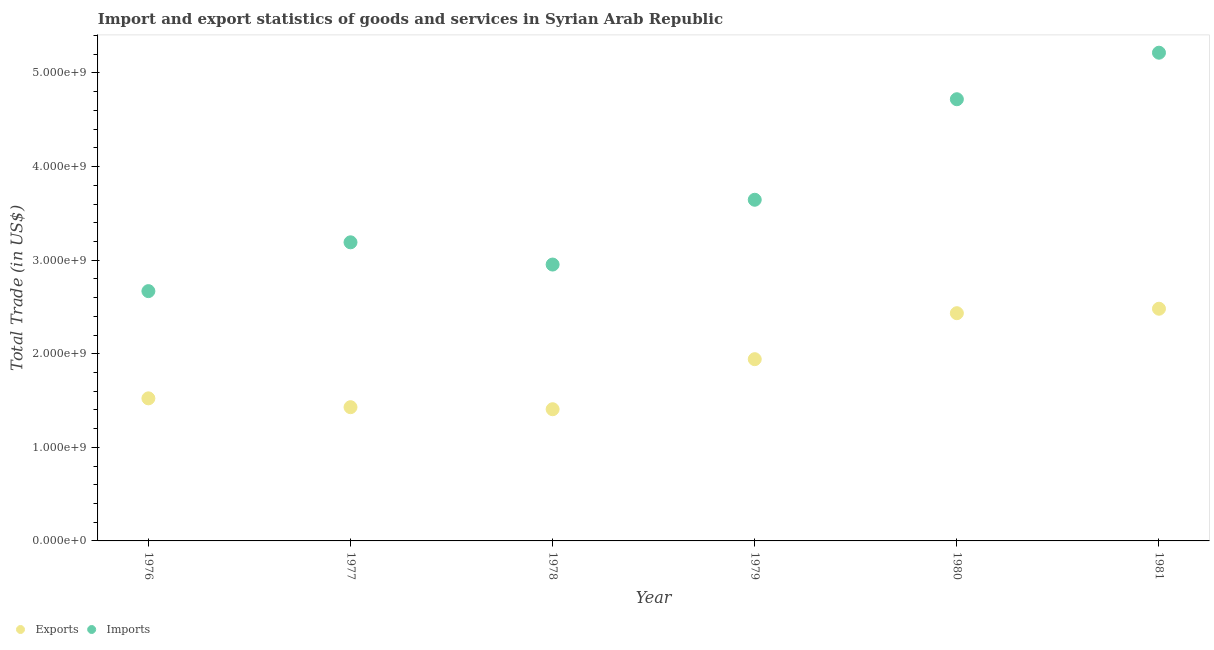What is the imports of goods and services in 1976?
Your response must be concise. 2.67e+09. Across all years, what is the maximum export of goods and services?
Your response must be concise. 2.48e+09. Across all years, what is the minimum export of goods and services?
Make the answer very short. 1.41e+09. In which year was the export of goods and services maximum?
Keep it short and to the point. 1981. In which year was the imports of goods and services minimum?
Give a very brief answer. 1976. What is the total imports of goods and services in the graph?
Your answer should be very brief. 2.24e+1. What is the difference between the imports of goods and services in 1979 and that in 1981?
Provide a succinct answer. -1.57e+09. What is the difference between the export of goods and services in 1979 and the imports of goods and services in 1977?
Provide a succinct answer. -1.25e+09. What is the average imports of goods and services per year?
Make the answer very short. 3.73e+09. In the year 1979, what is the difference between the export of goods and services and imports of goods and services?
Your response must be concise. -1.70e+09. In how many years, is the imports of goods and services greater than 1400000000 US$?
Your response must be concise. 6. What is the ratio of the export of goods and services in 1976 to that in 1980?
Offer a terse response. 0.63. Is the imports of goods and services in 1976 less than that in 1977?
Your answer should be compact. Yes. What is the difference between the highest and the second highest export of goods and services?
Provide a succinct answer. 4.78e+07. What is the difference between the highest and the lowest imports of goods and services?
Ensure brevity in your answer.  2.55e+09. Does the imports of goods and services monotonically increase over the years?
Ensure brevity in your answer.  No. Is the imports of goods and services strictly greater than the export of goods and services over the years?
Provide a short and direct response. Yes. How many dotlines are there?
Your answer should be compact. 2. How many years are there in the graph?
Provide a succinct answer. 6. What is the difference between two consecutive major ticks on the Y-axis?
Provide a short and direct response. 1.00e+09. What is the title of the graph?
Your answer should be compact. Import and export statistics of goods and services in Syrian Arab Republic. Does "Register a property" appear as one of the legend labels in the graph?
Ensure brevity in your answer.  No. What is the label or title of the X-axis?
Provide a succinct answer. Year. What is the label or title of the Y-axis?
Ensure brevity in your answer.  Total Trade (in US$). What is the Total Trade (in US$) in Exports in 1976?
Your response must be concise. 1.52e+09. What is the Total Trade (in US$) in Imports in 1976?
Your answer should be very brief. 2.67e+09. What is the Total Trade (in US$) in Exports in 1977?
Keep it short and to the point. 1.43e+09. What is the Total Trade (in US$) in Imports in 1977?
Provide a short and direct response. 3.19e+09. What is the Total Trade (in US$) in Exports in 1978?
Your response must be concise. 1.41e+09. What is the Total Trade (in US$) of Imports in 1978?
Make the answer very short. 2.95e+09. What is the Total Trade (in US$) in Exports in 1979?
Offer a terse response. 1.94e+09. What is the Total Trade (in US$) of Imports in 1979?
Your answer should be very brief. 3.65e+09. What is the Total Trade (in US$) in Exports in 1980?
Keep it short and to the point. 2.43e+09. What is the Total Trade (in US$) of Imports in 1980?
Give a very brief answer. 4.72e+09. What is the Total Trade (in US$) of Exports in 1981?
Make the answer very short. 2.48e+09. What is the Total Trade (in US$) of Imports in 1981?
Provide a short and direct response. 5.22e+09. Across all years, what is the maximum Total Trade (in US$) in Exports?
Make the answer very short. 2.48e+09. Across all years, what is the maximum Total Trade (in US$) in Imports?
Ensure brevity in your answer.  5.22e+09. Across all years, what is the minimum Total Trade (in US$) in Exports?
Your response must be concise. 1.41e+09. Across all years, what is the minimum Total Trade (in US$) in Imports?
Make the answer very short. 2.67e+09. What is the total Total Trade (in US$) of Exports in the graph?
Offer a terse response. 1.12e+1. What is the total Total Trade (in US$) of Imports in the graph?
Ensure brevity in your answer.  2.24e+1. What is the difference between the Total Trade (in US$) in Exports in 1976 and that in 1977?
Offer a terse response. 9.43e+07. What is the difference between the Total Trade (in US$) in Imports in 1976 and that in 1977?
Keep it short and to the point. -5.22e+08. What is the difference between the Total Trade (in US$) in Exports in 1976 and that in 1978?
Your answer should be compact. 1.16e+08. What is the difference between the Total Trade (in US$) in Imports in 1976 and that in 1978?
Your answer should be compact. -2.84e+08. What is the difference between the Total Trade (in US$) of Exports in 1976 and that in 1979?
Provide a short and direct response. -4.19e+08. What is the difference between the Total Trade (in US$) of Imports in 1976 and that in 1979?
Give a very brief answer. -9.76e+08. What is the difference between the Total Trade (in US$) in Exports in 1976 and that in 1980?
Ensure brevity in your answer.  -9.10e+08. What is the difference between the Total Trade (in US$) in Imports in 1976 and that in 1980?
Give a very brief answer. -2.05e+09. What is the difference between the Total Trade (in US$) of Exports in 1976 and that in 1981?
Give a very brief answer. -9.58e+08. What is the difference between the Total Trade (in US$) in Imports in 1976 and that in 1981?
Ensure brevity in your answer.  -2.55e+09. What is the difference between the Total Trade (in US$) in Exports in 1977 and that in 1978?
Make the answer very short. 2.19e+07. What is the difference between the Total Trade (in US$) of Imports in 1977 and that in 1978?
Offer a terse response. 2.38e+08. What is the difference between the Total Trade (in US$) in Exports in 1977 and that in 1979?
Provide a succinct answer. -5.13e+08. What is the difference between the Total Trade (in US$) of Imports in 1977 and that in 1979?
Provide a short and direct response. -4.55e+08. What is the difference between the Total Trade (in US$) of Exports in 1977 and that in 1980?
Provide a succinct answer. -1.00e+09. What is the difference between the Total Trade (in US$) of Imports in 1977 and that in 1980?
Your answer should be very brief. -1.53e+09. What is the difference between the Total Trade (in US$) in Exports in 1977 and that in 1981?
Make the answer very short. -1.05e+09. What is the difference between the Total Trade (in US$) of Imports in 1977 and that in 1981?
Your answer should be compact. -2.03e+09. What is the difference between the Total Trade (in US$) of Exports in 1978 and that in 1979?
Offer a very short reply. -5.35e+08. What is the difference between the Total Trade (in US$) of Imports in 1978 and that in 1979?
Provide a short and direct response. -6.92e+08. What is the difference between the Total Trade (in US$) in Exports in 1978 and that in 1980?
Make the answer very short. -1.03e+09. What is the difference between the Total Trade (in US$) in Imports in 1978 and that in 1980?
Provide a short and direct response. -1.77e+09. What is the difference between the Total Trade (in US$) of Exports in 1978 and that in 1981?
Your answer should be compact. -1.07e+09. What is the difference between the Total Trade (in US$) of Imports in 1978 and that in 1981?
Provide a short and direct response. -2.26e+09. What is the difference between the Total Trade (in US$) of Exports in 1979 and that in 1980?
Provide a short and direct response. -4.91e+08. What is the difference between the Total Trade (in US$) in Imports in 1979 and that in 1980?
Keep it short and to the point. -1.07e+09. What is the difference between the Total Trade (in US$) of Exports in 1979 and that in 1981?
Your response must be concise. -5.39e+08. What is the difference between the Total Trade (in US$) of Imports in 1979 and that in 1981?
Provide a short and direct response. -1.57e+09. What is the difference between the Total Trade (in US$) of Exports in 1980 and that in 1981?
Offer a very short reply. -4.78e+07. What is the difference between the Total Trade (in US$) in Imports in 1980 and that in 1981?
Your response must be concise. -4.97e+08. What is the difference between the Total Trade (in US$) of Exports in 1976 and the Total Trade (in US$) of Imports in 1977?
Provide a succinct answer. -1.67e+09. What is the difference between the Total Trade (in US$) of Exports in 1976 and the Total Trade (in US$) of Imports in 1978?
Ensure brevity in your answer.  -1.43e+09. What is the difference between the Total Trade (in US$) of Exports in 1976 and the Total Trade (in US$) of Imports in 1979?
Provide a succinct answer. -2.12e+09. What is the difference between the Total Trade (in US$) of Exports in 1976 and the Total Trade (in US$) of Imports in 1980?
Your answer should be compact. -3.20e+09. What is the difference between the Total Trade (in US$) in Exports in 1976 and the Total Trade (in US$) in Imports in 1981?
Give a very brief answer. -3.69e+09. What is the difference between the Total Trade (in US$) of Exports in 1977 and the Total Trade (in US$) of Imports in 1978?
Offer a very short reply. -1.52e+09. What is the difference between the Total Trade (in US$) in Exports in 1977 and the Total Trade (in US$) in Imports in 1979?
Provide a short and direct response. -2.22e+09. What is the difference between the Total Trade (in US$) in Exports in 1977 and the Total Trade (in US$) in Imports in 1980?
Give a very brief answer. -3.29e+09. What is the difference between the Total Trade (in US$) of Exports in 1977 and the Total Trade (in US$) of Imports in 1981?
Your answer should be very brief. -3.79e+09. What is the difference between the Total Trade (in US$) in Exports in 1978 and the Total Trade (in US$) in Imports in 1979?
Give a very brief answer. -2.24e+09. What is the difference between the Total Trade (in US$) of Exports in 1978 and the Total Trade (in US$) of Imports in 1980?
Keep it short and to the point. -3.31e+09. What is the difference between the Total Trade (in US$) in Exports in 1978 and the Total Trade (in US$) in Imports in 1981?
Your answer should be very brief. -3.81e+09. What is the difference between the Total Trade (in US$) in Exports in 1979 and the Total Trade (in US$) in Imports in 1980?
Make the answer very short. -2.78e+09. What is the difference between the Total Trade (in US$) of Exports in 1979 and the Total Trade (in US$) of Imports in 1981?
Provide a succinct answer. -3.27e+09. What is the difference between the Total Trade (in US$) in Exports in 1980 and the Total Trade (in US$) in Imports in 1981?
Make the answer very short. -2.78e+09. What is the average Total Trade (in US$) of Exports per year?
Offer a very short reply. 1.87e+09. What is the average Total Trade (in US$) of Imports per year?
Give a very brief answer. 3.73e+09. In the year 1976, what is the difference between the Total Trade (in US$) of Exports and Total Trade (in US$) of Imports?
Offer a very short reply. -1.15e+09. In the year 1977, what is the difference between the Total Trade (in US$) of Exports and Total Trade (in US$) of Imports?
Offer a very short reply. -1.76e+09. In the year 1978, what is the difference between the Total Trade (in US$) in Exports and Total Trade (in US$) in Imports?
Offer a very short reply. -1.55e+09. In the year 1979, what is the difference between the Total Trade (in US$) in Exports and Total Trade (in US$) in Imports?
Give a very brief answer. -1.70e+09. In the year 1980, what is the difference between the Total Trade (in US$) of Exports and Total Trade (in US$) of Imports?
Offer a very short reply. -2.29e+09. In the year 1981, what is the difference between the Total Trade (in US$) of Exports and Total Trade (in US$) of Imports?
Provide a succinct answer. -2.74e+09. What is the ratio of the Total Trade (in US$) in Exports in 1976 to that in 1977?
Offer a very short reply. 1.07. What is the ratio of the Total Trade (in US$) in Imports in 1976 to that in 1977?
Give a very brief answer. 0.84. What is the ratio of the Total Trade (in US$) in Exports in 1976 to that in 1978?
Ensure brevity in your answer.  1.08. What is the ratio of the Total Trade (in US$) in Imports in 1976 to that in 1978?
Provide a short and direct response. 0.9. What is the ratio of the Total Trade (in US$) of Exports in 1976 to that in 1979?
Your answer should be compact. 0.78. What is the ratio of the Total Trade (in US$) in Imports in 1976 to that in 1979?
Your answer should be very brief. 0.73. What is the ratio of the Total Trade (in US$) in Exports in 1976 to that in 1980?
Provide a short and direct response. 0.63. What is the ratio of the Total Trade (in US$) of Imports in 1976 to that in 1980?
Provide a short and direct response. 0.57. What is the ratio of the Total Trade (in US$) in Exports in 1976 to that in 1981?
Your answer should be compact. 0.61. What is the ratio of the Total Trade (in US$) of Imports in 1976 to that in 1981?
Your response must be concise. 0.51. What is the ratio of the Total Trade (in US$) in Exports in 1977 to that in 1978?
Your response must be concise. 1.02. What is the ratio of the Total Trade (in US$) of Imports in 1977 to that in 1978?
Provide a succinct answer. 1.08. What is the ratio of the Total Trade (in US$) of Exports in 1977 to that in 1979?
Provide a short and direct response. 0.74. What is the ratio of the Total Trade (in US$) of Imports in 1977 to that in 1979?
Offer a terse response. 0.88. What is the ratio of the Total Trade (in US$) of Exports in 1977 to that in 1980?
Your answer should be compact. 0.59. What is the ratio of the Total Trade (in US$) in Imports in 1977 to that in 1980?
Keep it short and to the point. 0.68. What is the ratio of the Total Trade (in US$) of Exports in 1977 to that in 1981?
Provide a succinct answer. 0.58. What is the ratio of the Total Trade (in US$) of Imports in 1977 to that in 1981?
Your answer should be very brief. 0.61. What is the ratio of the Total Trade (in US$) of Exports in 1978 to that in 1979?
Provide a short and direct response. 0.72. What is the ratio of the Total Trade (in US$) of Imports in 1978 to that in 1979?
Provide a short and direct response. 0.81. What is the ratio of the Total Trade (in US$) of Exports in 1978 to that in 1980?
Offer a terse response. 0.58. What is the ratio of the Total Trade (in US$) of Imports in 1978 to that in 1980?
Make the answer very short. 0.63. What is the ratio of the Total Trade (in US$) in Exports in 1978 to that in 1981?
Keep it short and to the point. 0.57. What is the ratio of the Total Trade (in US$) in Imports in 1978 to that in 1981?
Keep it short and to the point. 0.57. What is the ratio of the Total Trade (in US$) of Exports in 1979 to that in 1980?
Your answer should be very brief. 0.8. What is the ratio of the Total Trade (in US$) of Imports in 1979 to that in 1980?
Ensure brevity in your answer.  0.77. What is the ratio of the Total Trade (in US$) of Exports in 1979 to that in 1981?
Provide a short and direct response. 0.78. What is the ratio of the Total Trade (in US$) of Imports in 1979 to that in 1981?
Give a very brief answer. 0.7. What is the ratio of the Total Trade (in US$) in Exports in 1980 to that in 1981?
Your response must be concise. 0.98. What is the ratio of the Total Trade (in US$) of Imports in 1980 to that in 1981?
Your answer should be very brief. 0.9. What is the difference between the highest and the second highest Total Trade (in US$) in Exports?
Give a very brief answer. 4.78e+07. What is the difference between the highest and the second highest Total Trade (in US$) of Imports?
Offer a very short reply. 4.97e+08. What is the difference between the highest and the lowest Total Trade (in US$) in Exports?
Your response must be concise. 1.07e+09. What is the difference between the highest and the lowest Total Trade (in US$) in Imports?
Offer a terse response. 2.55e+09. 